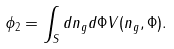Convert formula to latex. <formula><loc_0><loc_0><loc_500><loc_500>\phi _ { 2 } = \int _ { S } d n _ { g } d \Phi V ( n _ { g } , \Phi ) .</formula> 